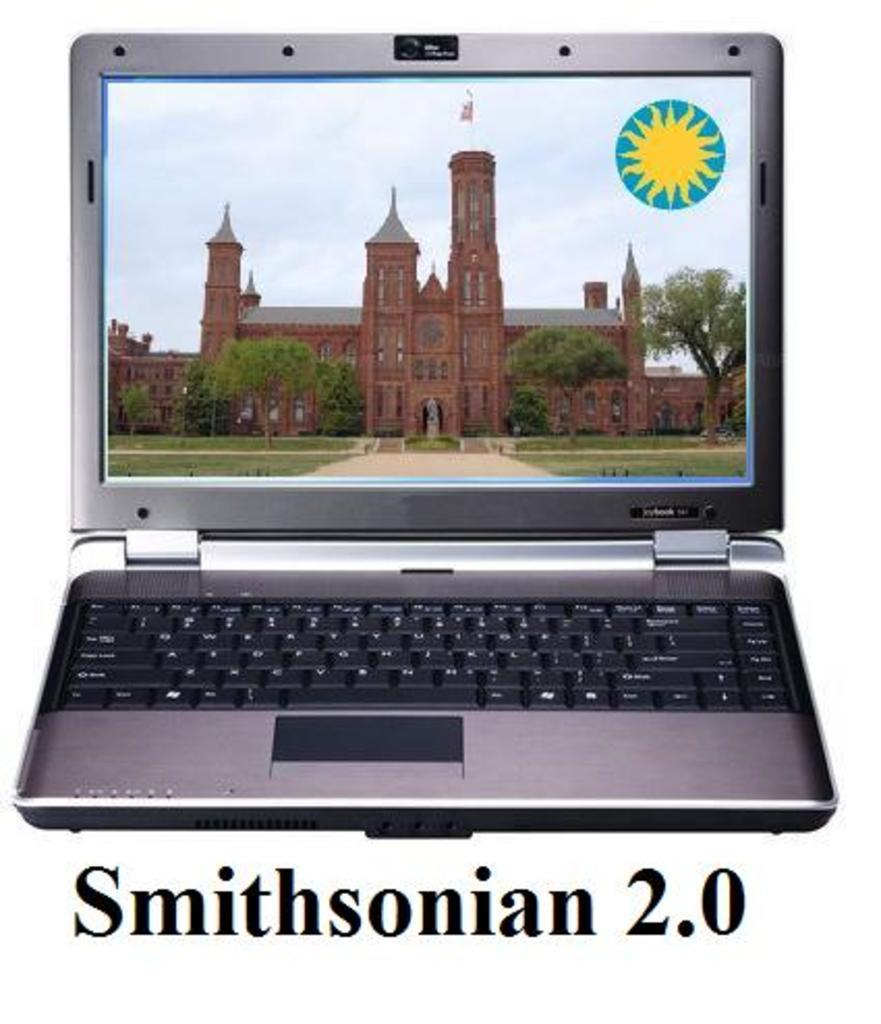<image>
Offer a succinct explanation of the picture presented. A laptop in a photo that says Smithsonian 2.0. 